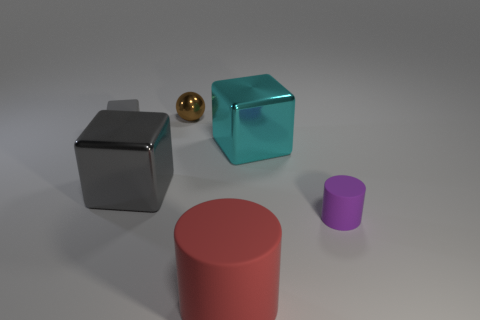Subtract all blue cubes. Subtract all red cylinders. How many cubes are left? 3 Add 1 gray metal blocks. How many objects exist? 7 Subtract all spheres. How many objects are left? 5 Subtract 1 red cylinders. How many objects are left? 5 Subtract all big gray things. Subtract all large cyan things. How many objects are left? 4 Add 1 cyan things. How many cyan things are left? 2 Add 1 tiny green metallic things. How many tiny green metallic things exist? 1 